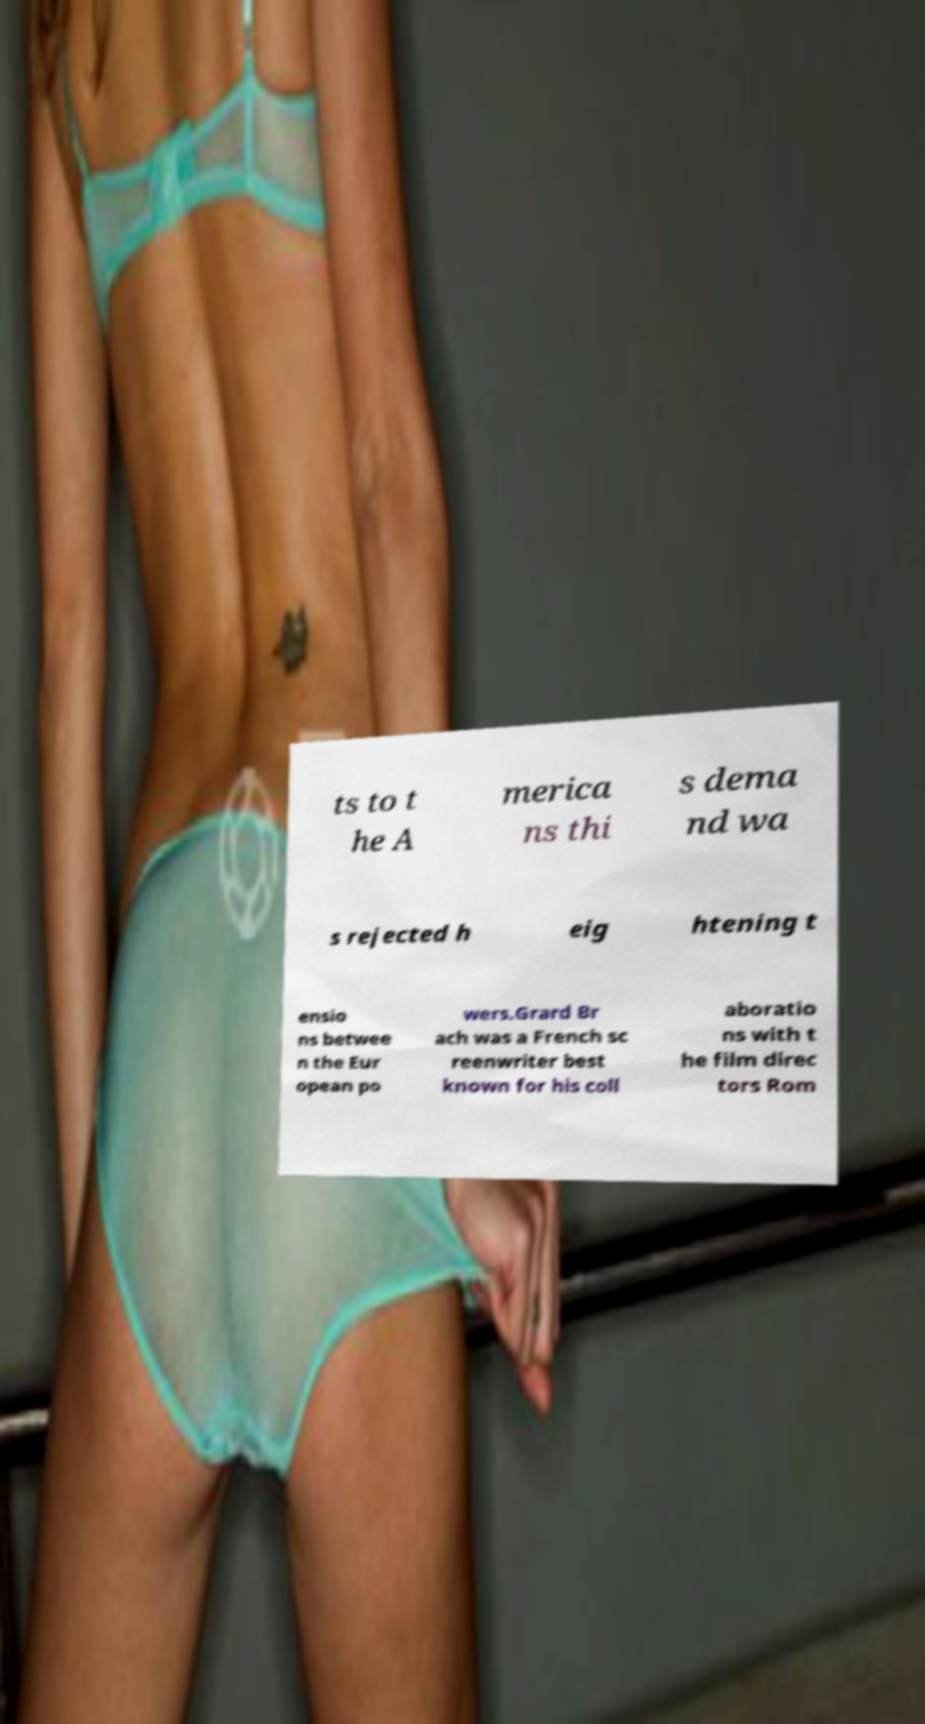Could you extract and type out the text from this image? ts to t he A merica ns thi s dema nd wa s rejected h eig htening t ensio ns betwee n the Eur opean po wers.Grard Br ach was a French sc reenwriter best known for his coll aboratio ns with t he film direc tors Rom 